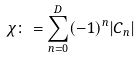Convert formula to latex. <formula><loc_0><loc_0><loc_500><loc_500>\chi \colon = \sum _ { n = 0 } ^ { D } ( - 1 ) ^ { n } | C _ { n } |</formula> 